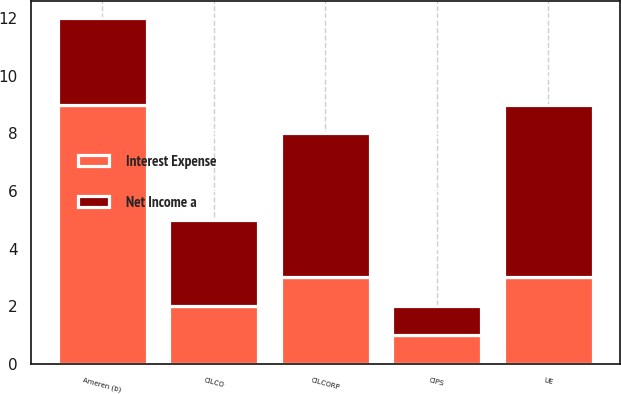Convert chart. <chart><loc_0><loc_0><loc_500><loc_500><stacked_bar_chart><ecel><fcel>Ameren (b)<fcel>UE<fcel>CIPS<fcel>CILCORP<fcel>CILCO<nl><fcel>Net Income a<fcel>3<fcel>6<fcel>1<fcel>5<fcel>3<nl><fcel>Interest Expense<fcel>9<fcel>3<fcel>1<fcel>3<fcel>2<nl></chart> 